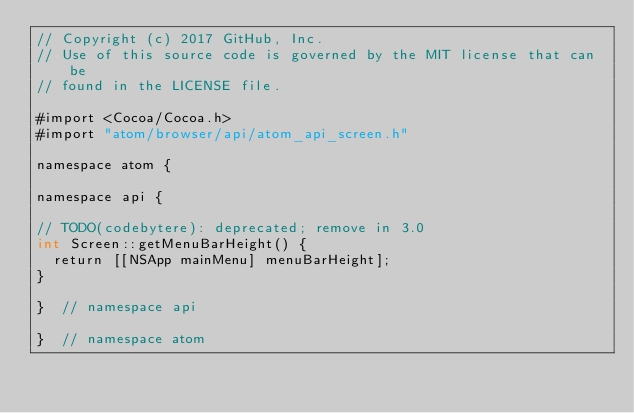<code> <loc_0><loc_0><loc_500><loc_500><_ObjectiveC_>// Copyright (c) 2017 GitHub, Inc.
// Use of this source code is governed by the MIT license that can be
// found in the LICENSE file.

#import <Cocoa/Cocoa.h>
#import "atom/browser/api/atom_api_screen.h"

namespace atom {

namespace api {

// TODO(codebytere): deprecated; remove in 3.0
int Screen::getMenuBarHeight() {
  return [[NSApp mainMenu] menuBarHeight];
}

}  // namespace api

}  // namespace atom
</code> 